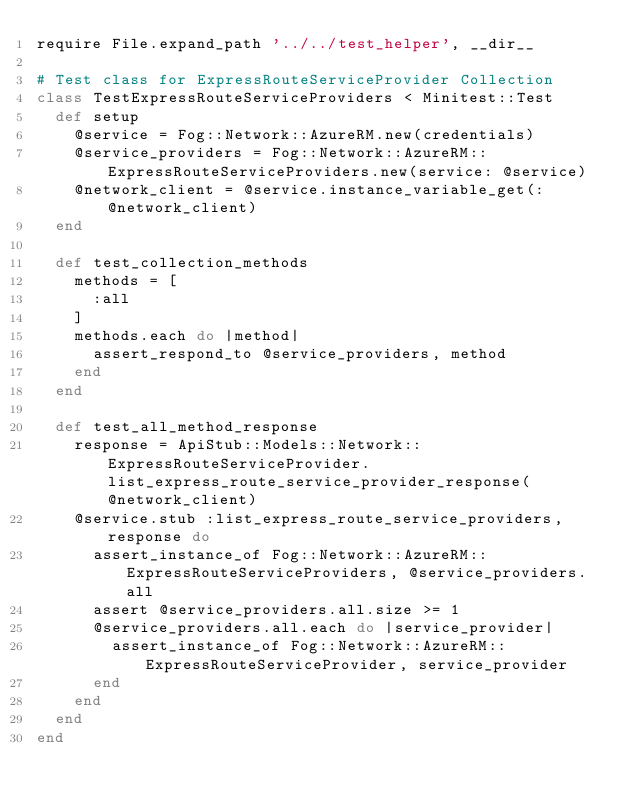<code> <loc_0><loc_0><loc_500><loc_500><_Ruby_>require File.expand_path '../../test_helper', __dir__

# Test class for ExpressRouteServiceProvider Collection
class TestExpressRouteServiceProviders < Minitest::Test
  def setup
    @service = Fog::Network::AzureRM.new(credentials)
    @service_providers = Fog::Network::AzureRM::ExpressRouteServiceProviders.new(service: @service)
    @network_client = @service.instance_variable_get(:@network_client)
  end

  def test_collection_methods
    methods = [
      :all
    ]
    methods.each do |method|
      assert_respond_to @service_providers, method
    end
  end

  def test_all_method_response
    response = ApiStub::Models::Network::ExpressRouteServiceProvider.list_express_route_service_provider_response(@network_client)
    @service.stub :list_express_route_service_providers, response do
      assert_instance_of Fog::Network::AzureRM::ExpressRouteServiceProviders, @service_providers.all
      assert @service_providers.all.size >= 1
      @service_providers.all.each do |service_provider|
        assert_instance_of Fog::Network::AzureRM::ExpressRouteServiceProvider, service_provider
      end
    end
  end
end
</code> 